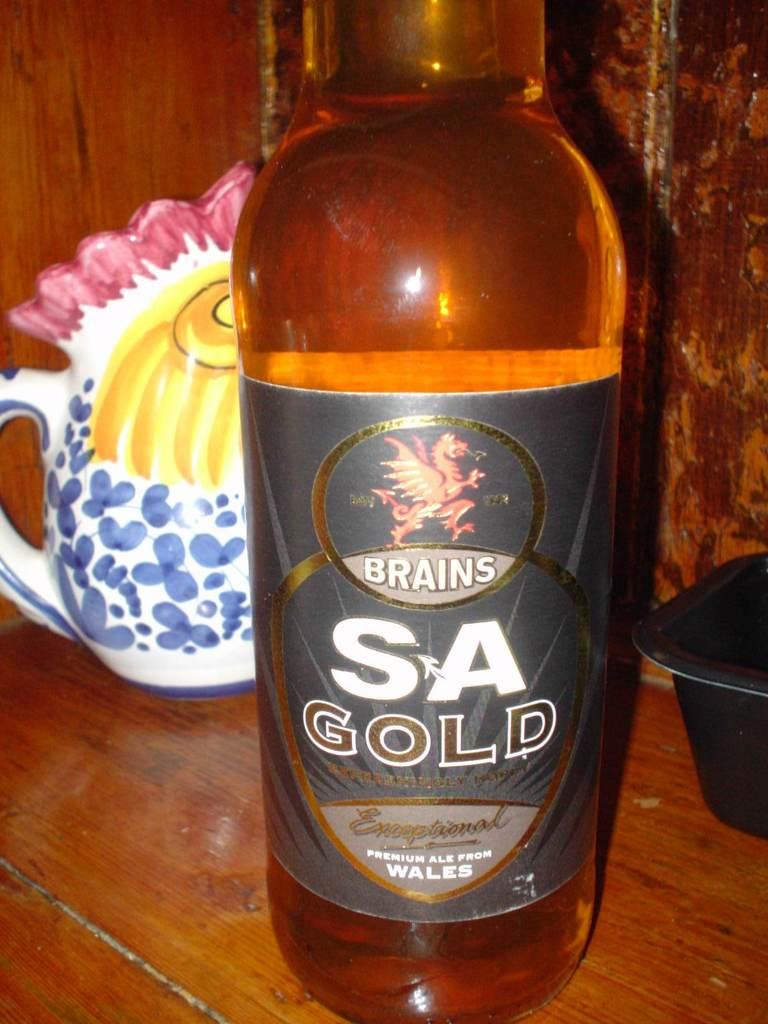<image>
Render a clear and concise summary of the photo. A bottle of a welsh ale is on a wooden table in front of a ceramic kettle. 